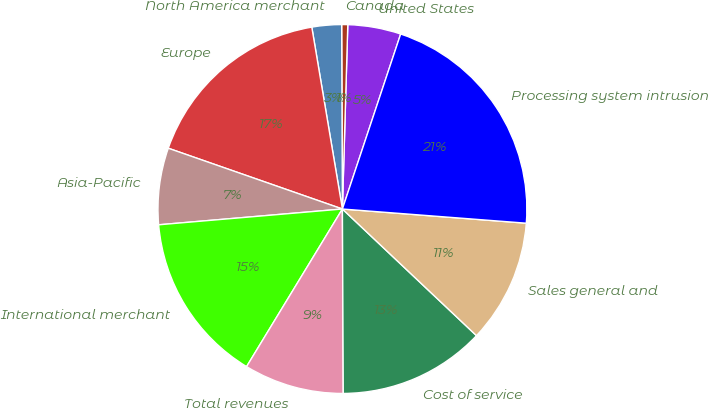Convert chart to OTSL. <chart><loc_0><loc_0><loc_500><loc_500><pie_chart><fcel>United States<fcel>Canada<fcel>North America merchant<fcel>Europe<fcel>Asia-Pacific<fcel>International merchant<fcel>Total revenues<fcel>Cost of service<fcel>Sales general and<fcel>Processing system intrusion<nl><fcel>4.65%<fcel>0.53%<fcel>2.59%<fcel>17.0%<fcel>6.71%<fcel>14.94%<fcel>8.77%<fcel>12.88%<fcel>10.82%<fcel>21.11%<nl></chart> 